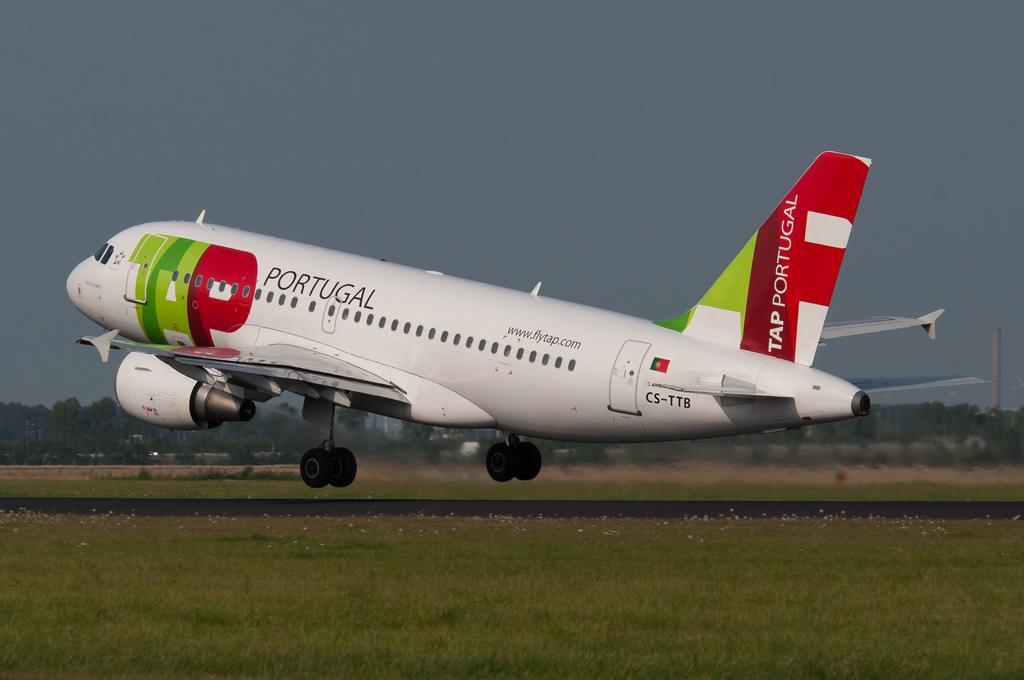Describe this image in one or two sentences. In the center of the image we can see an aeroplane flying. At the bottom there is grass and we can see a runway. In the background there are trees and sky. 